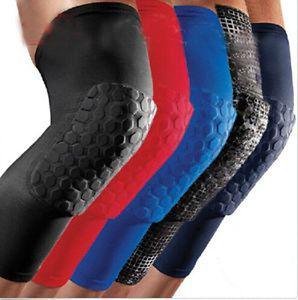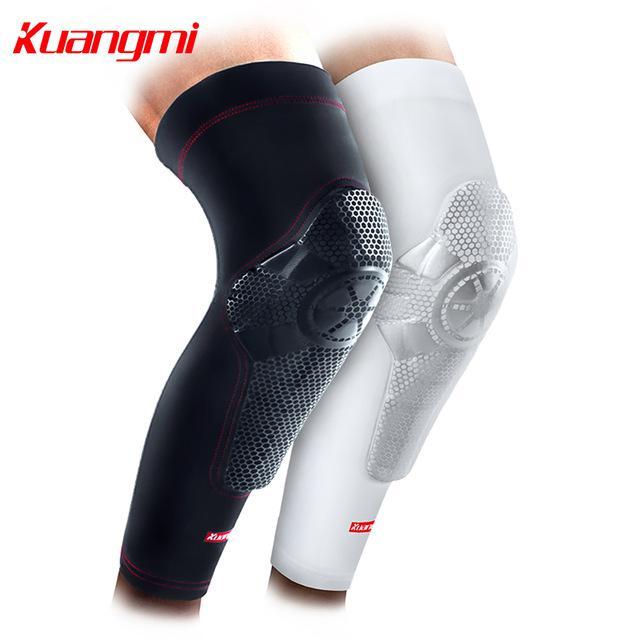The first image is the image on the left, the second image is the image on the right. For the images shown, is this caption "In the right image, only the leg on the left is wearing a knee wrap, and the pair of legs are in black shorts." true? Answer yes or no. No. The first image is the image on the left, the second image is the image on the right. Given the left and right images, does the statement "The left and right image contains a total of seven knee braces." hold true? Answer yes or no. Yes. 